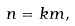<formula> <loc_0><loc_0><loc_500><loc_500>n = k m ,</formula> 